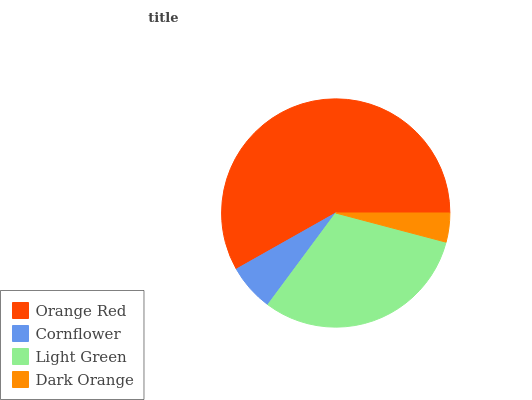Is Dark Orange the minimum?
Answer yes or no. Yes. Is Orange Red the maximum?
Answer yes or no. Yes. Is Cornflower the minimum?
Answer yes or no. No. Is Cornflower the maximum?
Answer yes or no. No. Is Orange Red greater than Cornflower?
Answer yes or no. Yes. Is Cornflower less than Orange Red?
Answer yes or no. Yes. Is Cornflower greater than Orange Red?
Answer yes or no. No. Is Orange Red less than Cornflower?
Answer yes or no. No. Is Light Green the high median?
Answer yes or no. Yes. Is Cornflower the low median?
Answer yes or no. Yes. Is Cornflower the high median?
Answer yes or no. No. Is Dark Orange the low median?
Answer yes or no. No. 